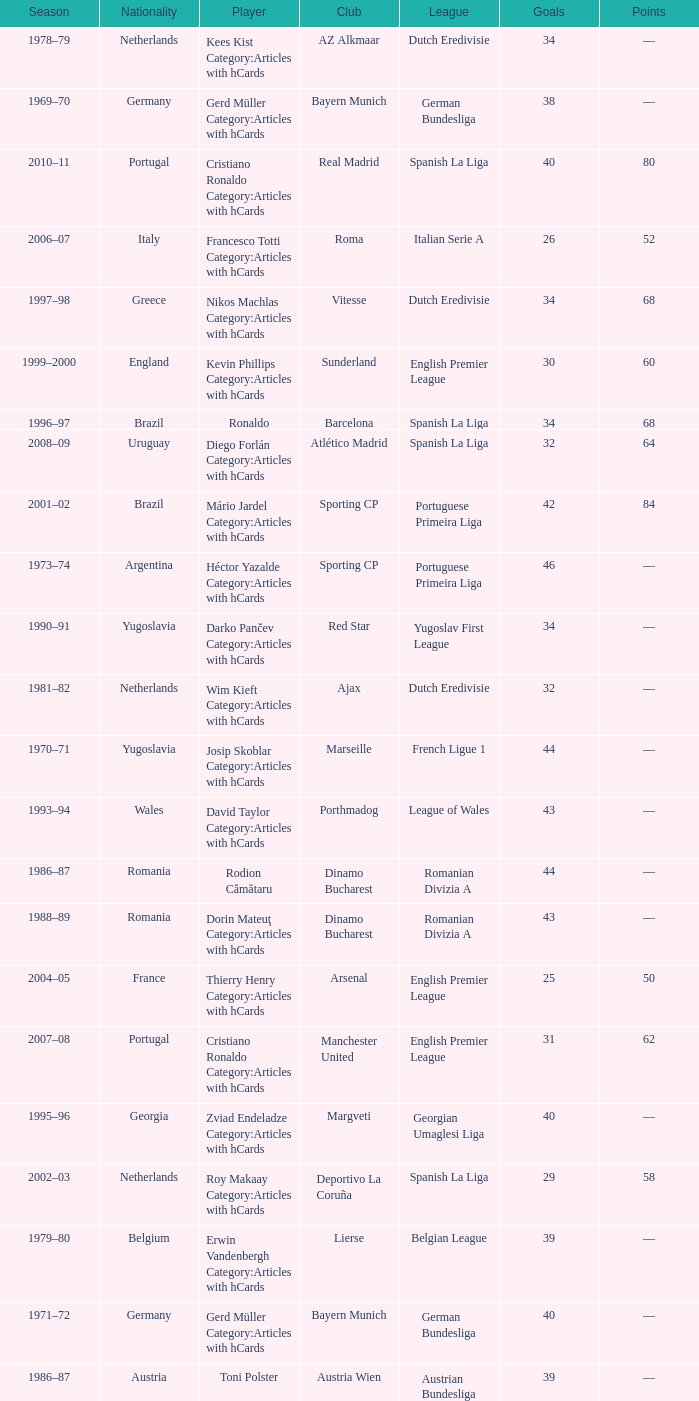Which player was in the Omonia Nicosia club? Sotiris Kaiafas Category:Articles with hCards. 